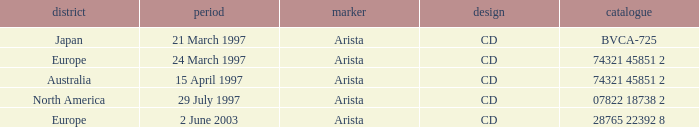What's the Date for the Region of Europe and has the Catalog of 28765 22392 8? 2 June 2003. 